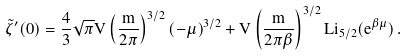Convert formula to latex. <formula><loc_0><loc_0><loc_500><loc_500>\tilde { \zeta } ^ { \prime } ( 0 ) = \frac { 4 } { 3 } \sqrt { \pi } V \left ( \frac { m } { 2 \pi } \right ) ^ { 3 / 2 } ( - \mu ) ^ { 3 / 2 } + V \left ( \frac { m } { 2 \pi \beta } \right ) ^ { 3 / 2 } L i _ { 5 / 2 } ( e ^ { \beta \mu } ) \, .</formula> 